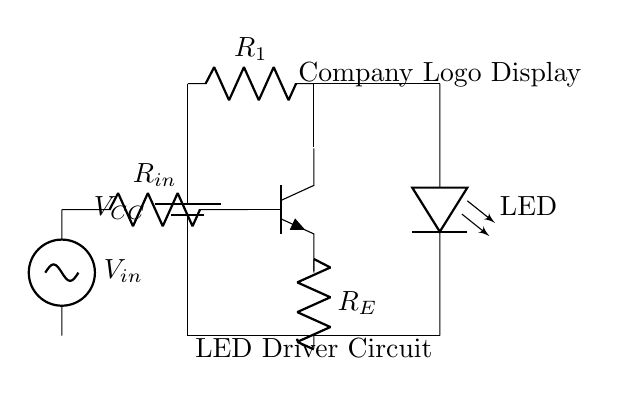What type of transistor is used in this circuit? The circuit uses an NPN transistor, which is indicated by the label on the symbol in the diagram.
Answer: NPN What is the purpose of resistor R1 in this circuit? Resistor R1 is used to limit the current flowing into the base of the transistor, which is essential for controlling the transistor's operation.
Answer: Current limiting What component provides the input voltage in the circuit? The input voltage is provided by the voltage source labeled V_in, which is connected to the base of the NPN transistor.
Answer: Voltage source What is the role of the LED in this circuit? The LED is the output component that lights up, indicating that the transistor is turned on, and it visually represents the company logo display.
Answer: Illumination How does the current flow through the circuit when V_in is applied? When V_in is positive, current flows through R_in into the base of the NPN transistor, allowing it to conduct and enabling current to flow from the collector to the emitter, subsequently lighting up the LED.
Answer: Current flows through base to collector What is the function of resistor R_E in the circuit? Resistor R_E is an emitter resistor that helps stabilize the transistor's operation by providing negative feedback, which improves the linearity of the amplifier.
Answer: Stabilization What happens to the LED when the input voltage V_in is removed? When V_in is removed, the base current stops, the transistor turns off, and no current flows through the LED, causing it to turn off.
Answer: LED turns off 